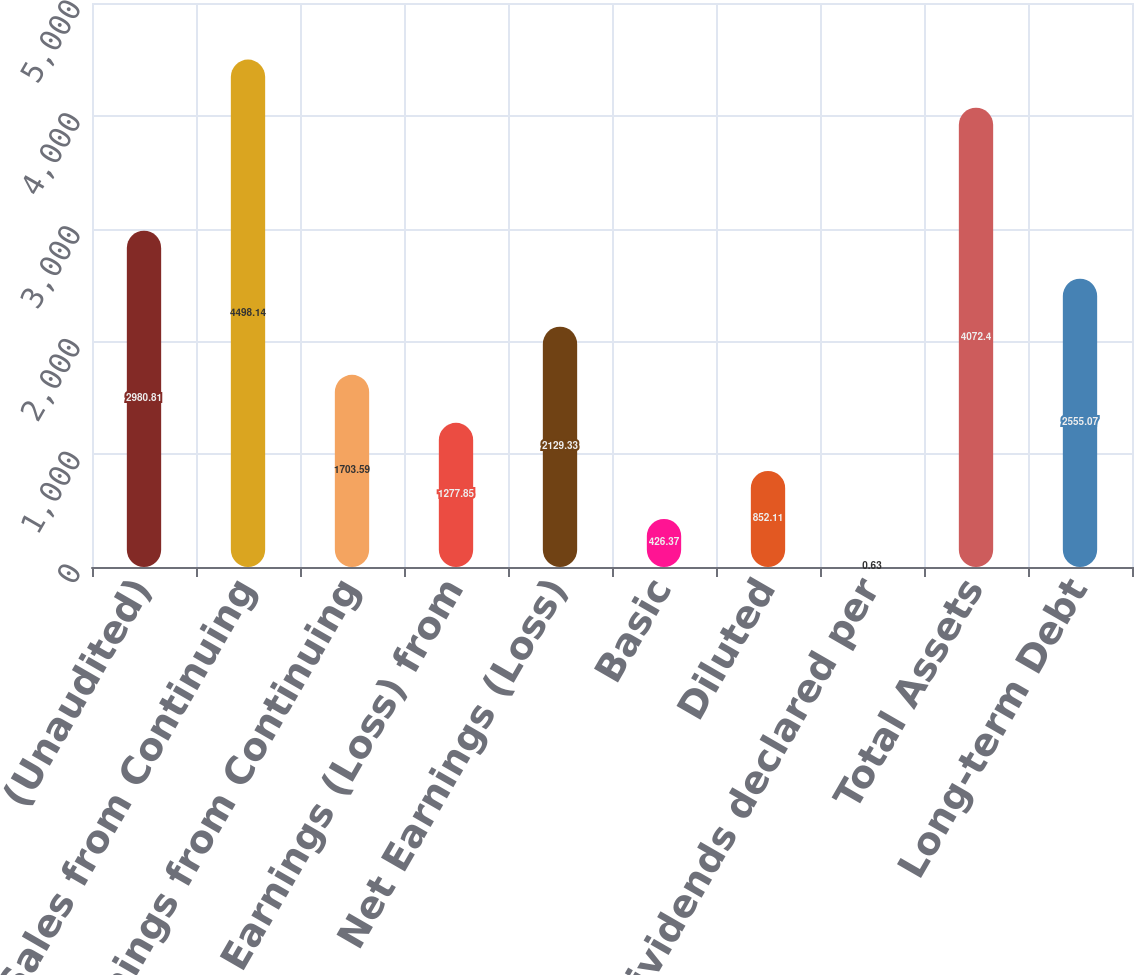<chart> <loc_0><loc_0><loc_500><loc_500><bar_chart><fcel>(Unaudited)<fcel>Net Sales from Continuing<fcel>Net Earnings from Continuing<fcel>Net Earnings (Loss) from<fcel>Net Earnings (Loss)<fcel>Basic<fcel>Diluted<fcel>Cash Dividends declared per<fcel>Total Assets<fcel>Long-term Debt<nl><fcel>2980.81<fcel>4498.14<fcel>1703.59<fcel>1277.85<fcel>2129.33<fcel>426.37<fcel>852.11<fcel>0.63<fcel>4072.4<fcel>2555.07<nl></chart> 